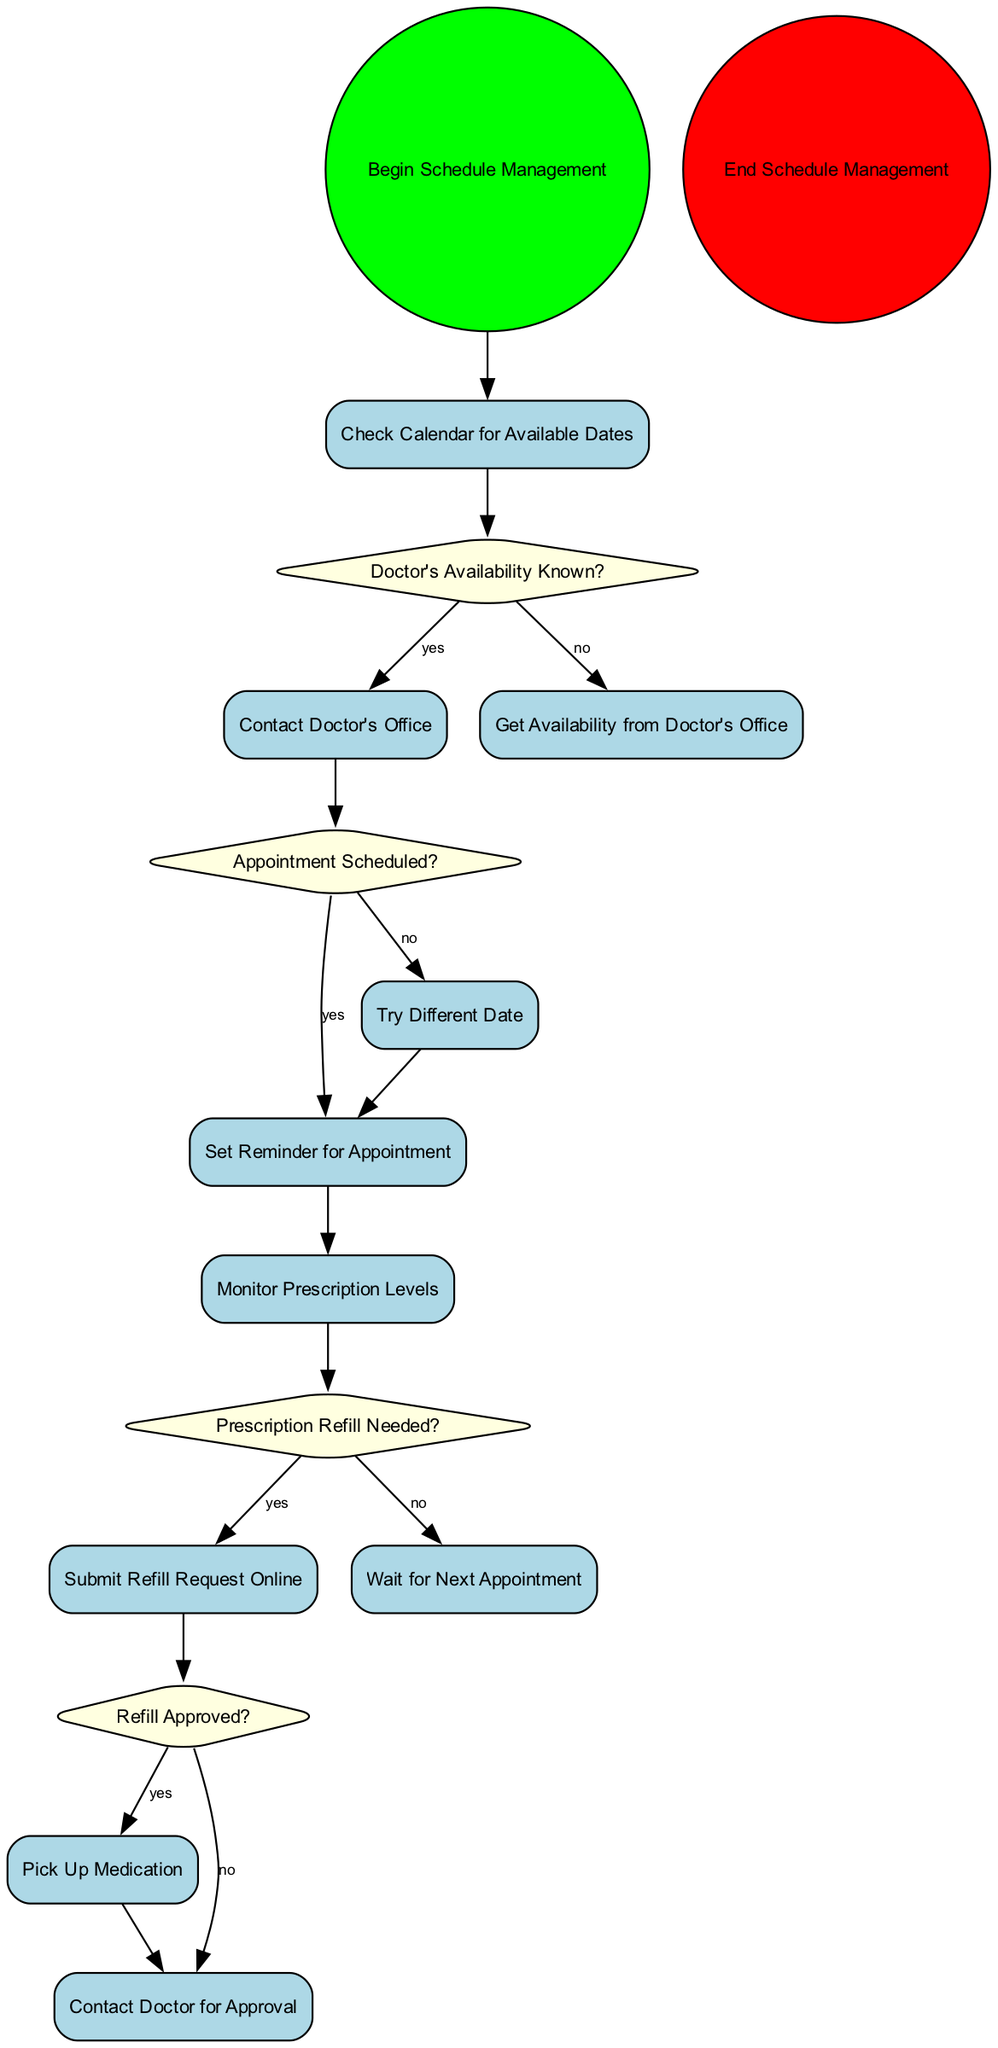What is the first activity in the diagram? The diagram starts with the node named "Begin Schedule Management", which indicates the starting point of the scheduling process.
Answer: Begin Schedule Management How many decision nodes are present in the diagram? Upon reviewing the diagram, there are three decision nodes: "Doctor's Availability Known?", "Appointment Scheduled?", and "Prescription Refill Needed?".
Answer: 3 What happens if the doctor's availability is known? If the doctor's availability is known, the process moves to the activity "Contact Doctor's Office". This is a direct branch from the decision node indicating "yes".
Answer: Contact Doctor's Office What is the outcome if the refill request is needed? If a prescription refill is needed, the process leads to submitting a refill request online, which is determined by the decision node "Prescription Refill Needed?" where the "yes" branch directs to the activity "Submit Refill Request Online".
Answer: Submit Refill Request Online What action follows after successfully scheduling an appointment? After successfully scheduling an appointment, the next action in the flow is "Set Reminder for Appointment", which follows the "yes" branch from the decision node "Appointment Scheduled?".
Answer: Set Reminder for Appointment What is the final node in the activity diagram? The final node in this activity diagram is named "End Schedule Management", which symbolizes the conclusion of the scheduling process.
Answer: End Schedule Management What condition leads to trying a different date for the appointment? If the appointment is not scheduled, which is determined by the decision node "Appointment Scheduled?" with the "no" branch, the flow leads to the activity "Try Different Date".
Answer: Try Different Date What is required to pick up medication? To pick up medication, the refill must be approved, as indicated by the decision node "Refill Approved?" where the "yes" branch directs to the activity "Pick Up Medication".
Answer: Pick Up Medication 